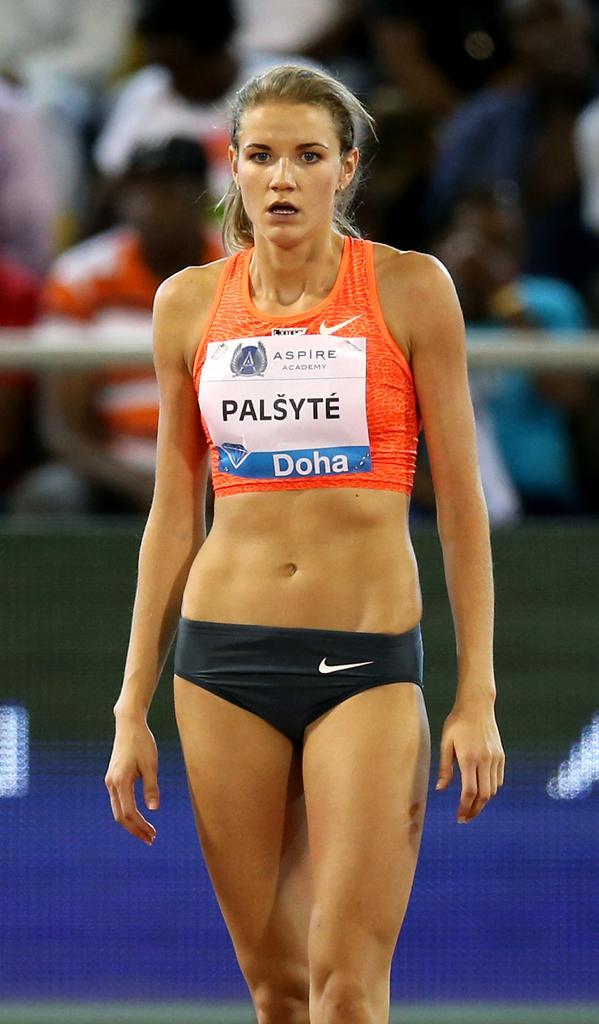Describe this image in one or two sentences. In this picture there is a woman standing. At the back there are group of people sitting behind the rod and there is a board. 